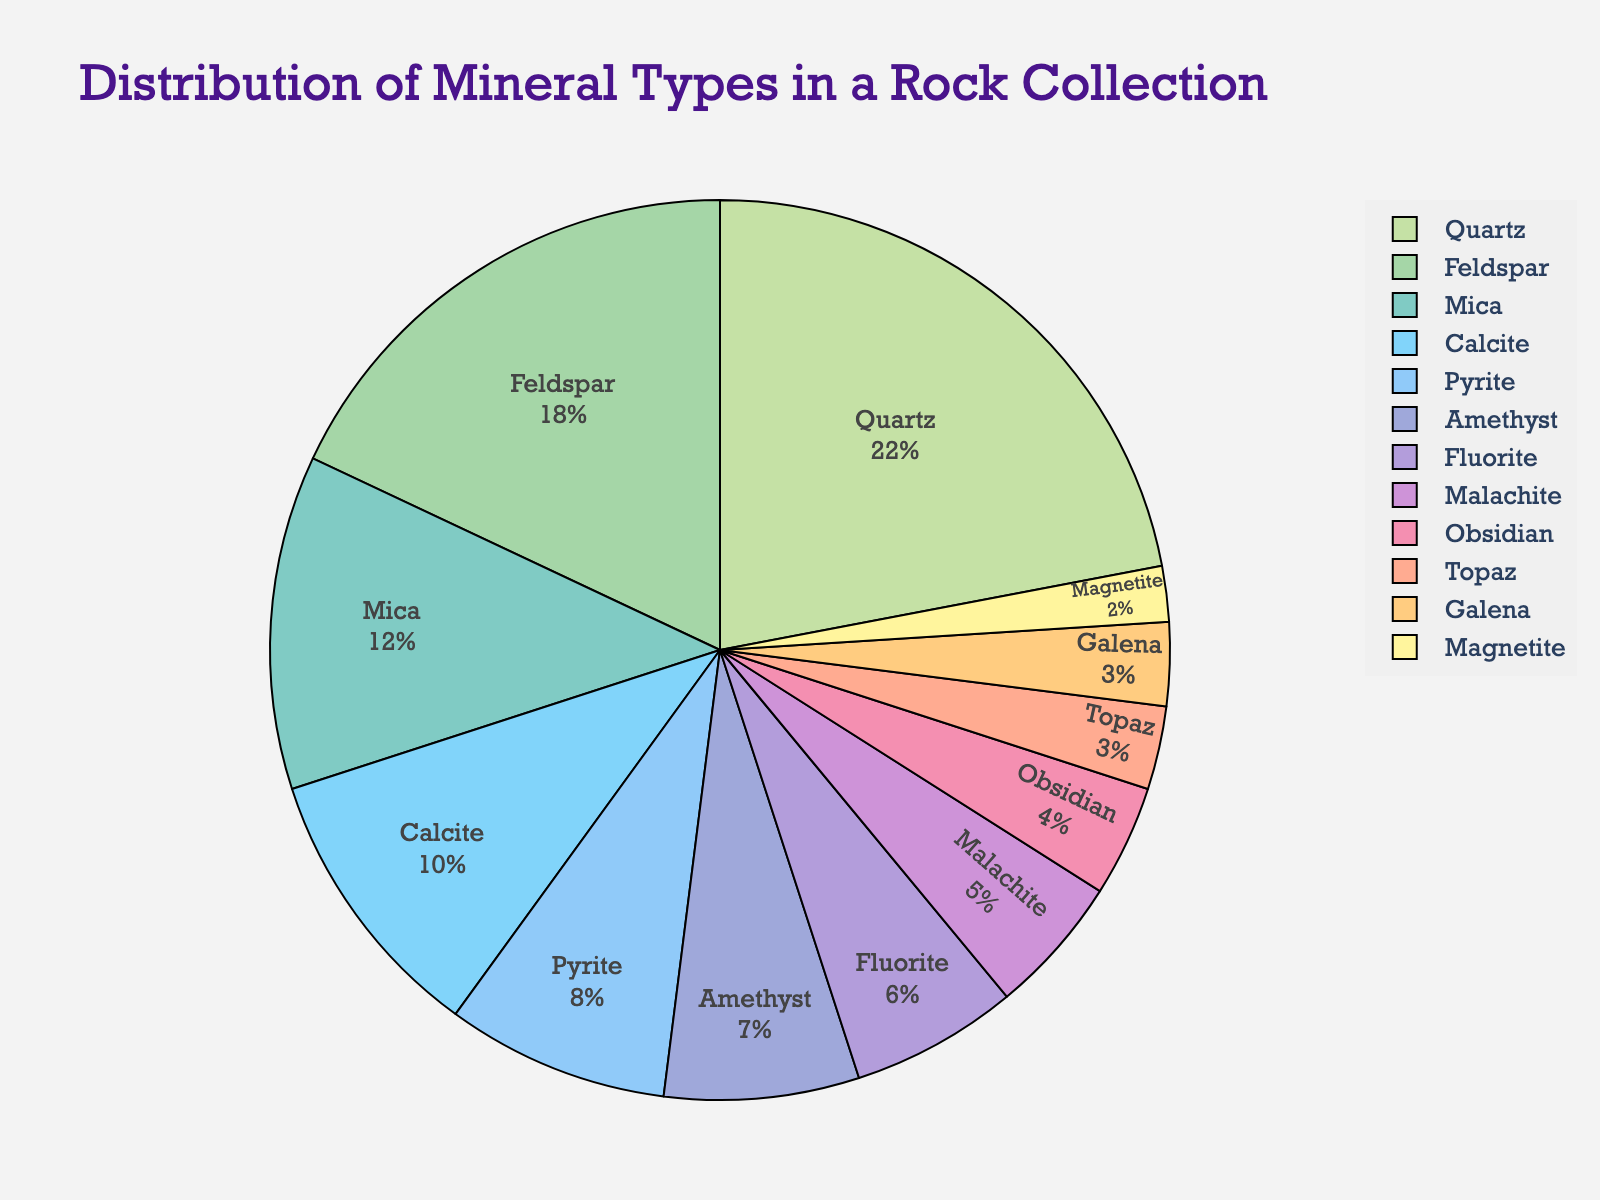Which mineral type has the highest percentage in the rock collection? By looking at the pie chart, you can see that Quartz occupies the largest segment of the chart.
Answer: Quartz What is the combined percentage of Mica and Calcite in the rock collection? Mica has a percentage of 12% and Calcite has 10%. Adding these together gives 12% + 10% = 22%.
Answer: 22% Which has a smaller percentage, Pyrite or Amethyst? By comparing the pie chart segments for Pyrite and Amethyst, you can see that Amethyst occupies a smaller segment.
Answer: Amethyst Is the percentage of Quartz in the rock collection greater than that of Feldspar and Mica combined? Feldspar and Mica together make up 18% + 12% = 30%. Since Quartz is 22%, Quartz's percentage is less than the combined percentage of Feldspar and Mica.
Answer: No What is the range (difference between highest and lowest) of the mineral percentages? The highest percentage is Quartz at 22%; the lowest is Magnetite at 2%. The range is 22% - 2% = 20%.
Answer: 20% How does the percentage of Obsidian compare to that of Topaz and Galena combined? Obsidian is 4%, while Topaz and Galena combined are 3% + 3% = 6%. Obsidian's percentage is smaller.
Answer: Smaller How many mineral types constitute less than 5% of the rock collection each? The minerals that make up less than 5% are Obsidian, Topaz, Galena, and Magnetite, making a total of 4 types.
Answer: 4 If you sum the percentages of the least represented five minerals, what do you get? The least represented minerals are Obsidian (4%), Topaz (3%), Galena (3%), Magnetite (2%), and Malachite (5%), adding up to 4% + 3% + 3% + 2% + 5% = 17%.
Answer: 17% 